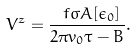Convert formula to latex. <formula><loc_0><loc_0><loc_500><loc_500>V ^ { z } = \frac { \ f \sigma A [ \epsilon _ { 0 } ] } { 2 \pi v _ { 0 } \tau - B } .</formula> 